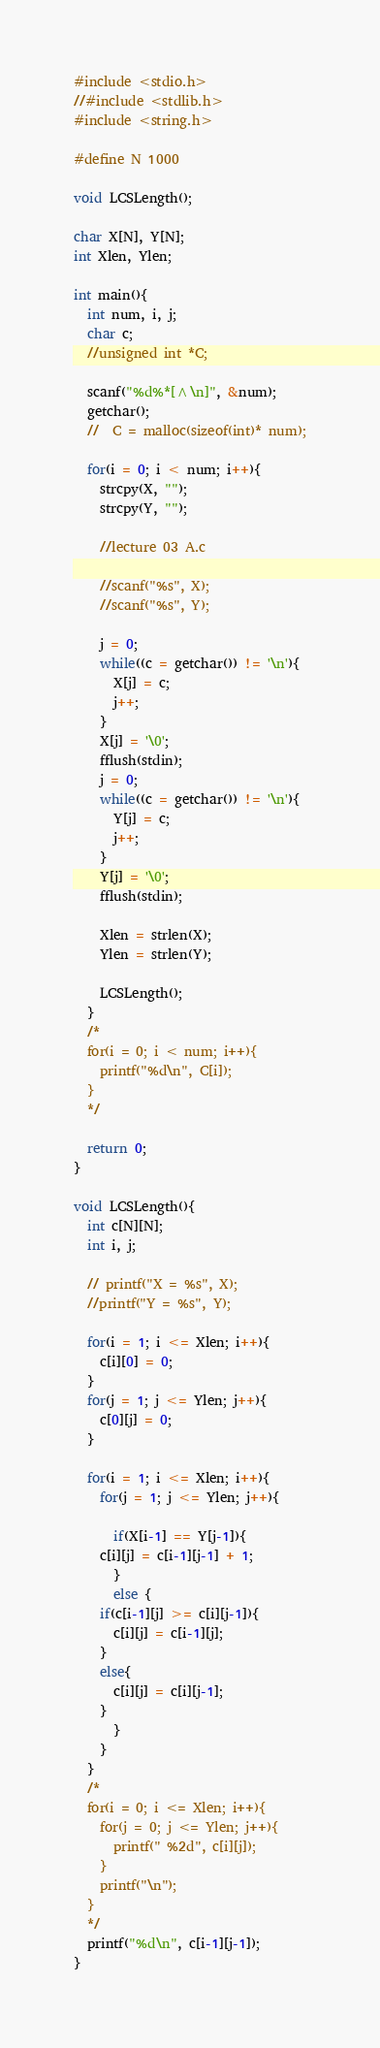Convert code to text. <code><loc_0><loc_0><loc_500><loc_500><_C_>#include <stdio.h>
//#include <stdlib.h>
#include <string.h>

#define N 1000

void LCSLength();

char X[N], Y[N];
int Xlen, Ylen;

int main(){
  int num, i, j;
  char c;
  //unsigned int *C;

  scanf("%d%*[^\n]", &num);
  getchar();
  //  C = malloc(sizeof(int)* num);
  
  for(i = 0; i < num; i++){
    strcpy(X, "");
    strcpy(Y, "");

    //lecture 03 A.c 
    
    //scanf("%s", X);
    //scanf("%s", Y);
    
    j = 0;
    while((c = getchar()) != '\n'){
      X[j] = c;
      j++;
    }
    X[j] = '\0';
    fflush(stdin);
    j = 0;
    while((c = getchar()) != '\n'){
      Y[j] = c;
      j++;
    }
    Y[j] = '\0';
    fflush(stdin);
    
    Xlen = strlen(X);
    Ylen = strlen(Y);

    LCSLength();
  }
  /*
  for(i = 0; i < num; i++){
    printf("%d\n", C[i]);
  }
  */
  
  return 0;
}

void LCSLength(){
  int c[N][N];
  int i, j;

  // printf("X = %s", X);
  //printf("Y = %s", Y);
  
  for(i = 1; i <= Xlen; i++){
    c[i][0] = 0;
  }
  for(j = 1; j <= Ylen; j++){
    c[0][j] = 0;
  }

  for(i = 1; i <= Xlen; i++){
    for(j = 1; j <= Ylen; j++){
      
      if(X[i-1] == Y[j-1]){
	c[i][j] = c[i-1][j-1] + 1;
      }
      else {
	if(c[i-1][j] >= c[i][j-1]){
	  c[i][j] = c[i-1][j];
	}
	else{
	  c[i][j] = c[i][j-1];
	}
      }
    }
  }
  /*
  for(i = 0; i <= Xlen; i++){
    for(j = 0; j <= Ylen; j++){
      printf(" %2d", c[i][j]);
    }
    printf("\n");
  }
  */
  printf("%d\n", c[i-1][j-1]);
}

</code> 